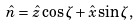<formula> <loc_0><loc_0><loc_500><loc_500>\hat { n } = \hat { z } \cos \zeta + \hat { x } \sin \zeta ,</formula> 